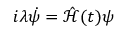<formula> <loc_0><loc_0><loc_500><loc_500>i \lambda \dot { \psi } = \hat { \mathcal { H } } ( t ) \psi</formula> 